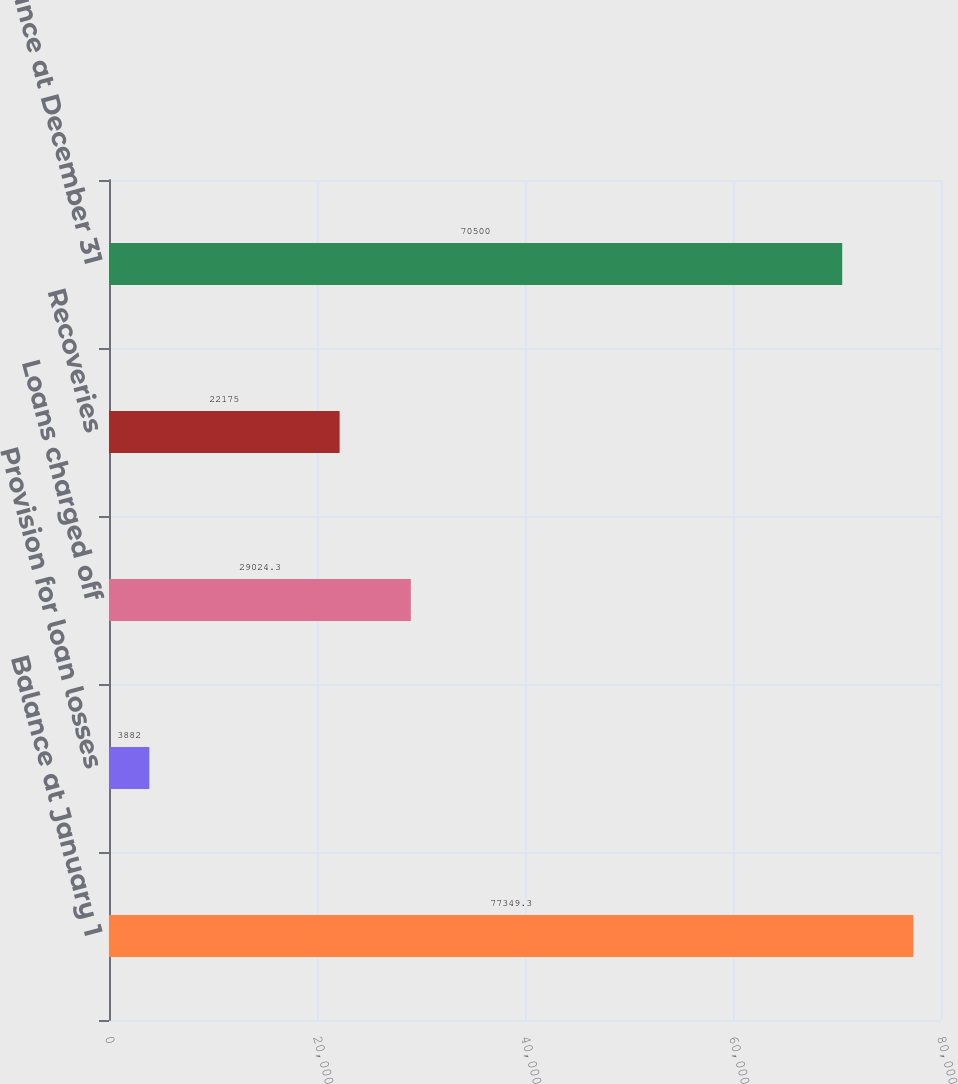Convert chart. <chart><loc_0><loc_0><loc_500><loc_500><bar_chart><fcel>Balance at January 1<fcel>Provision for loan losses<fcel>Loans charged off<fcel>Recoveries<fcel>Balance at December 31<nl><fcel>77349.3<fcel>3882<fcel>29024.3<fcel>22175<fcel>70500<nl></chart> 